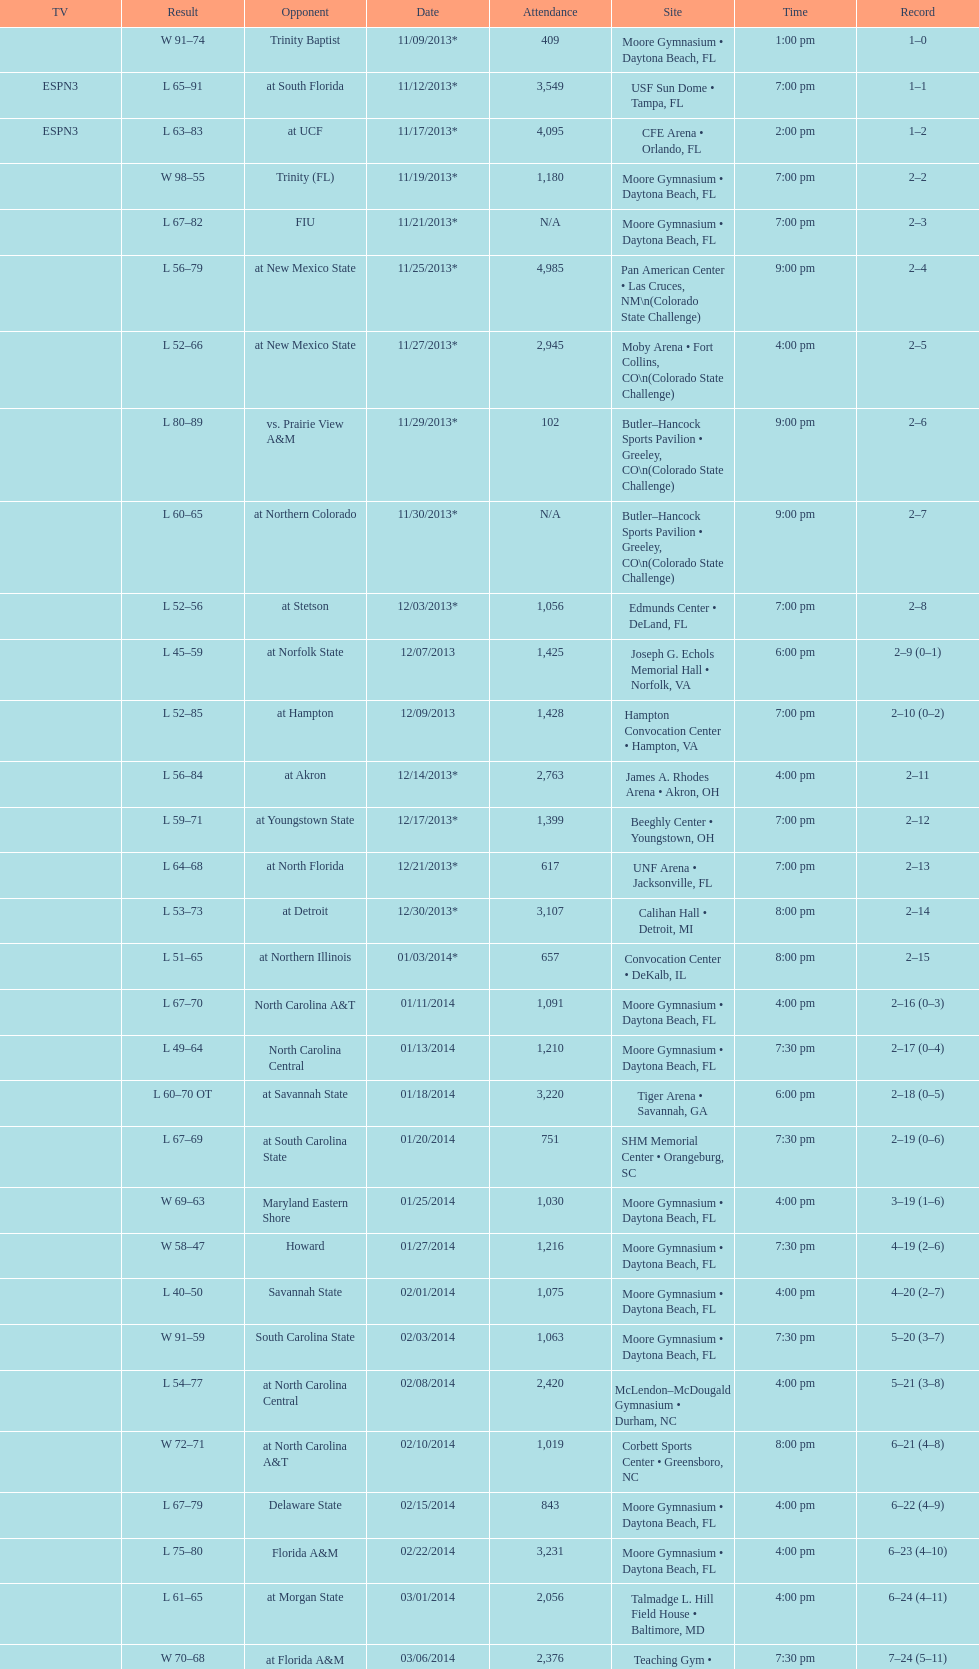How much larger was the attendance on 11/25/2013 than 12/21/2013? 4368. Give me the full table as a dictionary. {'header': ['TV', 'Result', 'Opponent', 'Date', 'Attendance', 'Site', 'Time', 'Record'], 'rows': [['', 'W\xa091–74', 'Trinity Baptist', '11/09/2013*', '409', 'Moore Gymnasium • Daytona Beach, FL', '1:00 pm', '1–0'], ['ESPN3', 'L\xa065–91', 'at\xa0South Florida', '11/12/2013*', '3,549', 'USF Sun Dome • Tampa, FL', '7:00 pm', '1–1'], ['ESPN3', 'L\xa063–83', 'at\xa0UCF', '11/17/2013*', '4,095', 'CFE Arena • Orlando, FL', '2:00 pm', '1–2'], ['', 'W\xa098–55', 'Trinity (FL)', '11/19/2013*', '1,180', 'Moore Gymnasium • Daytona Beach, FL', '7:00 pm', '2–2'], ['', 'L\xa067–82', 'FIU', '11/21/2013*', 'N/A', 'Moore Gymnasium • Daytona Beach, FL', '7:00 pm', '2–3'], ['', 'L\xa056–79', 'at\xa0New Mexico State', '11/25/2013*', '4,985', 'Pan American Center • Las Cruces, NM\\n(Colorado State Challenge)', '9:00 pm', '2–4'], ['', 'L\xa052–66', 'at\xa0New Mexico State', '11/27/2013*', '2,945', 'Moby Arena • Fort Collins, CO\\n(Colorado State Challenge)', '4:00 pm', '2–5'], ['', 'L\xa080–89', 'vs.\xa0Prairie View A&M', '11/29/2013*', '102', 'Butler–Hancock Sports Pavilion • Greeley, CO\\n(Colorado State Challenge)', '9:00 pm', '2–6'], ['', 'L\xa060–65', 'at\xa0Northern Colorado', '11/30/2013*', 'N/A', 'Butler–Hancock Sports Pavilion • Greeley, CO\\n(Colorado State Challenge)', '9:00 pm', '2–7'], ['', 'L\xa052–56', 'at\xa0Stetson', '12/03/2013*', '1,056', 'Edmunds Center • DeLand, FL', '7:00 pm', '2–8'], ['', 'L\xa045–59', 'at\xa0Norfolk State', '12/07/2013', '1,425', 'Joseph G. Echols Memorial Hall • Norfolk, VA', '6:00 pm', '2–9 (0–1)'], ['', 'L\xa052–85', 'at\xa0Hampton', '12/09/2013', '1,428', 'Hampton Convocation Center • Hampton, VA', '7:00 pm', '2–10 (0–2)'], ['', 'L\xa056–84', 'at\xa0Akron', '12/14/2013*', '2,763', 'James A. Rhodes Arena • Akron, OH', '4:00 pm', '2–11'], ['', 'L\xa059–71', 'at\xa0Youngstown State', '12/17/2013*', '1,399', 'Beeghly Center • Youngstown, OH', '7:00 pm', '2–12'], ['', 'L\xa064–68', 'at\xa0North Florida', '12/21/2013*', '617', 'UNF Arena • Jacksonville, FL', '7:00 pm', '2–13'], ['', 'L\xa053–73', 'at\xa0Detroit', '12/30/2013*', '3,107', 'Calihan Hall • Detroit, MI', '8:00 pm', '2–14'], ['', 'L\xa051–65', 'at\xa0Northern Illinois', '01/03/2014*', '657', 'Convocation Center • DeKalb, IL', '8:00 pm', '2–15'], ['', 'L\xa067–70', 'North Carolina A&T', '01/11/2014', '1,091', 'Moore Gymnasium • Daytona Beach, FL', '4:00 pm', '2–16 (0–3)'], ['', 'L\xa049–64', 'North Carolina Central', '01/13/2014', '1,210', 'Moore Gymnasium • Daytona Beach, FL', '7:30 pm', '2–17 (0–4)'], ['', 'L\xa060–70\xa0OT', 'at\xa0Savannah State', '01/18/2014', '3,220', 'Tiger Arena • Savannah, GA', '6:00 pm', '2–18 (0–5)'], ['', 'L\xa067–69', 'at\xa0South Carolina State', '01/20/2014', '751', 'SHM Memorial Center • Orangeburg, SC', '7:30 pm', '2–19 (0–6)'], ['', 'W\xa069–63', 'Maryland Eastern Shore', '01/25/2014', '1,030', 'Moore Gymnasium • Daytona Beach, FL', '4:00 pm', '3–19 (1–6)'], ['', 'W\xa058–47', 'Howard', '01/27/2014', '1,216', 'Moore Gymnasium • Daytona Beach, FL', '7:30 pm', '4–19 (2–6)'], ['', 'L\xa040–50', 'Savannah State', '02/01/2014', '1,075', 'Moore Gymnasium • Daytona Beach, FL', '4:00 pm', '4–20 (2–7)'], ['', 'W\xa091–59', 'South Carolina State', '02/03/2014', '1,063', 'Moore Gymnasium • Daytona Beach, FL', '7:30 pm', '5–20 (3–7)'], ['', 'L\xa054–77', 'at\xa0North Carolina Central', '02/08/2014', '2,420', 'McLendon–McDougald Gymnasium • Durham, NC', '4:00 pm', '5–21 (3–8)'], ['', 'W\xa072–71', 'at\xa0North Carolina A&T', '02/10/2014', '1,019', 'Corbett Sports Center • Greensboro, NC', '8:00 pm', '6–21 (4–8)'], ['', 'L\xa067–79', 'Delaware State', '02/15/2014', '843', 'Moore Gymnasium • Daytona Beach, FL', '4:00 pm', '6–22 (4–9)'], ['', 'L\xa075–80', 'Florida A&M', '02/22/2014', '3,231', 'Moore Gymnasium • Daytona Beach, FL', '4:00 pm', '6–23 (4–10)'], ['', 'L\xa061–65', 'at\xa0Morgan State', '03/01/2014', '2,056', 'Talmadge L. Hill Field House • Baltimore, MD', '4:00 pm', '6–24 (4–11)'], ['', 'W\xa070–68', 'at\xa0Florida A&M', '03/06/2014', '2,376', 'Teaching Gym • Tallahassee, FL', '7:30 pm', '7–24 (5–11)'], ['', 'L\xa068–75', 'vs.\xa0Coppin State', '03/11/2014', '4,658', 'Norfolk Scope • Norfolk, VA\\n(First round)', '6:30 pm', '7–25']]} 